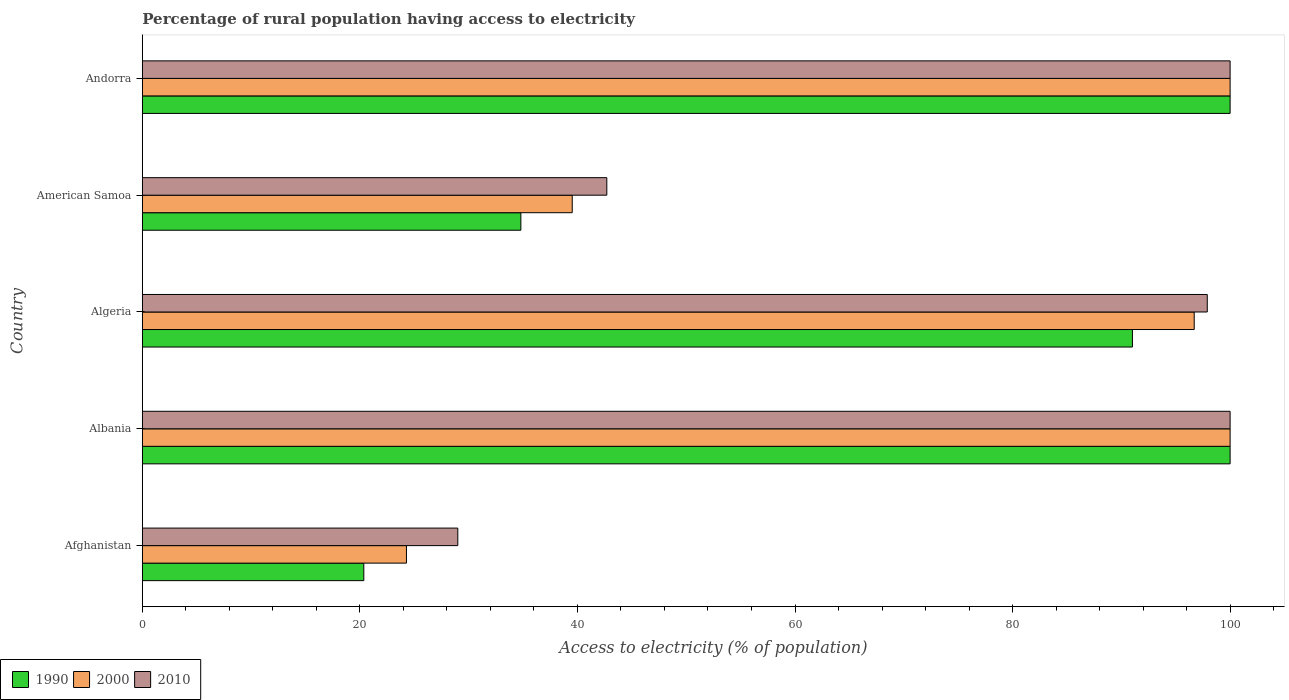Are the number of bars per tick equal to the number of legend labels?
Make the answer very short. Yes. Are the number of bars on each tick of the Y-axis equal?
Give a very brief answer. Yes. How many bars are there on the 4th tick from the bottom?
Ensure brevity in your answer.  3. What is the label of the 5th group of bars from the top?
Ensure brevity in your answer.  Afghanistan. What is the percentage of rural population having access to electricity in 2000 in American Samoa?
Your response must be concise. 39.52. In which country was the percentage of rural population having access to electricity in 2010 maximum?
Ensure brevity in your answer.  Albania. In which country was the percentage of rural population having access to electricity in 1990 minimum?
Keep it short and to the point. Afghanistan. What is the total percentage of rural population having access to electricity in 2000 in the graph?
Ensure brevity in your answer.  360.5. What is the difference between the percentage of rural population having access to electricity in 2010 in Afghanistan and that in Algeria?
Offer a terse response. -68.9. What is the difference between the percentage of rural population having access to electricity in 2000 in Andorra and the percentage of rural population having access to electricity in 1990 in Algeria?
Give a very brief answer. 8.98. What is the average percentage of rural population having access to electricity in 2010 per country?
Provide a succinct answer. 73.92. What is the difference between the percentage of rural population having access to electricity in 2010 and percentage of rural population having access to electricity in 2000 in Afghanistan?
Offer a terse response. 4.72. What is the ratio of the percentage of rural population having access to electricity in 2000 in Afghanistan to that in American Samoa?
Your response must be concise. 0.61. Is the percentage of rural population having access to electricity in 1990 in Albania less than that in Andorra?
Offer a terse response. No. Is the difference between the percentage of rural population having access to electricity in 2010 in Afghanistan and Albania greater than the difference between the percentage of rural population having access to electricity in 2000 in Afghanistan and Albania?
Ensure brevity in your answer.  Yes. Is the sum of the percentage of rural population having access to electricity in 2010 in Afghanistan and American Samoa greater than the maximum percentage of rural population having access to electricity in 2000 across all countries?
Your answer should be very brief. No. How many bars are there?
Give a very brief answer. 15. How many countries are there in the graph?
Make the answer very short. 5. Does the graph contain grids?
Your answer should be very brief. No. What is the title of the graph?
Keep it short and to the point. Percentage of rural population having access to electricity. Does "1968" appear as one of the legend labels in the graph?
Offer a very short reply. No. What is the label or title of the X-axis?
Offer a terse response. Access to electricity (% of population). What is the Access to electricity (% of population) in 1990 in Afghanistan?
Provide a short and direct response. 20.36. What is the Access to electricity (% of population) in 2000 in Afghanistan?
Ensure brevity in your answer.  24.28. What is the Access to electricity (% of population) in 2010 in Afghanistan?
Make the answer very short. 29. What is the Access to electricity (% of population) in 2000 in Albania?
Offer a very short reply. 100. What is the Access to electricity (% of population) in 2010 in Albania?
Offer a very short reply. 100. What is the Access to electricity (% of population) in 1990 in Algeria?
Keep it short and to the point. 91.02. What is the Access to electricity (% of population) in 2000 in Algeria?
Your answer should be very brief. 96.7. What is the Access to electricity (% of population) of 2010 in Algeria?
Offer a very short reply. 97.9. What is the Access to electricity (% of population) of 1990 in American Samoa?
Ensure brevity in your answer.  34.8. What is the Access to electricity (% of population) of 2000 in American Samoa?
Offer a terse response. 39.52. What is the Access to electricity (% of population) in 2010 in American Samoa?
Offer a terse response. 42.7. What is the Access to electricity (% of population) in 1990 in Andorra?
Ensure brevity in your answer.  100. What is the Access to electricity (% of population) of 2010 in Andorra?
Give a very brief answer. 100. Across all countries, what is the maximum Access to electricity (% of population) in 1990?
Your response must be concise. 100. Across all countries, what is the minimum Access to electricity (% of population) in 1990?
Provide a succinct answer. 20.36. Across all countries, what is the minimum Access to electricity (% of population) in 2000?
Your response must be concise. 24.28. What is the total Access to electricity (% of population) of 1990 in the graph?
Provide a succinct answer. 346.18. What is the total Access to electricity (% of population) of 2000 in the graph?
Provide a succinct answer. 360.5. What is the total Access to electricity (% of population) in 2010 in the graph?
Your answer should be very brief. 369.6. What is the difference between the Access to electricity (% of population) of 1990 in Afghanistan and that in Albania?
Provide a succinct answer. -79.64. What is the difference between the Access to electricity (% of population) of 2000 in Afghanistan and that in Albania?
Make the answer very short. -75.72. What is the difference between the Access to electricity (% of population) of 2010 in Afghanistan and that in Albania?
Offer a terse response. -71. What is the difference between the Access to electricity (% of population) in 1990 in Afghanistan and that in Algeria?
Provide a succinct answer. -70.66. What is the difference between the Access to electricity (% of population) in 2000 in Afghanistan and that in Algeria?
Offer a terse response. -72.42. What is the difference between the Access to electricity (% of population) of 2010 in Afghanistan and that in Algeria?
Provide a succinct answer. -68.9. What is the difference between the Access to electricity (% of population) of 1990 in Afghanistan and that in American Samoa?
Offer a very short reply. -14.44. What is the difference between the Access to electricity (% of population) in 2000 in Afghanistan and that in American Samoa?
Your answer should be very brief. -15.24. What is the difference between the Access to electricity (% of population) in 2010 in Afghanistan and that in American Samoa?
Your response must be concise. -13.7. What is the difference between the Access to electricity (% of population) of 1990 in Afghanistan and that in Andorra?
Your response must be concise. -79.64. What is the difference between the Access to electricity (% of population) in 2000 in Afghanistan and that in Andorra?
Your answer should be compact. -75.72. What is the difference between the Access to electricity (% of population) in 2010 in Afghanistan and that in Andorra?
Offer a very short reply. -71. What is the difference between the Access to electricity (% of population) in 1990 in Albania and that in Algeria?
Provide a succinct answer. 8.98. What is the difference between the Access to electricity (% of population) of 2010 in Albania and that in Algeria?
Provide a short and direct response. 2.1. What is the difference between the Access to electricity (% of population) in 1990 in Albania and that in American Samoa?
Provide a short and direct response. 65.2. What is the difference between the Access to electricity (% of population) of 2000 in Albania and that in American Samoa?
Offer a terse response. 60.48. What is the difference between the Access to electricity (% of population) of 2010 in Albania and that in American Samoa?
Make the answer very short. 57.3. What is the difference between the Access to electricity (% of population) in 1990 in Albania and that in Andorra?
Ensure brevity in your answer.  0. What is the difference between the Access to electricity (% of population) of 2000 in Albania and that in Andorra?
Your answer should be compact. 0. What is the difference between the Access to electricity (% of population) of 1990 in Algeria and that in American Samoa?
Make the answer very short. 56.22. What is the difference between the Access to electricity (% of population) of 2000 in Algeria and that in American Samoa?
Give a very brief answer. 57.18. What is the difference between the Access to electricity (% of population) of 2010 in Algeria and that in American Samoa?
Your answer should be compact. 55.2. What is the difference between the Access to electricity (% of population) of 1990 in Algeria and that in Andorra?
Your answer should be compact. -8.98. What is the difference between the Access to electricity (% of population) in 2000 in Algeria and that in Andorra?
Keep it short and to the point. -3.3. What is the difference between the Access to electricity (% of population) of 1990 in American Samoa and that in Andorra?
Your answer should be compact. -65.2. What is the difference between the Access to electricity (% of population) of 2000 in American Samoa and that in Andorra?
Provide a short and direct response. -60.48. What is the difference between the Access to electricity (% of population) in 2010 in American Samoa and that in Andorra?
Provide a short and direct response. -57.3. What is the difference between the Access to electricity (% of population) in 1990 in Afghanistan and the Access to electricity (% of population) in 2000 in Albania?
Provide a succinct answer. -79.64. What is the difference between the Access to electricity (% of population) of 1990 in Afghanistan and the Access to electricity (% of population) of 2010 in Albania?
Your response must be concise. -79.64. What is the difference between the Access to electricity (% of population) of 2000 in Afghanistan and the Access to electricity (% of population) of 2010 in Albania?
Keep it short and to the point. -75.72. What is the difference between the Access to electricity (% of population) in 1990 in Afghanistan and the Access to electricity (% of population) in 2000 in Algeria?
Your answer should be compact. -76.34. What is the difference between the Access to electricity (% of population) of 1990 in Afghanistan and the Access to electricity (% of population) of 2010 in Algeria?
Provide a succinct answer. -77.54. What is the difference between the Access to electricity (% of population) of 2000 in Afghanistan and the Access to electricity (% of population) of 2010 in Algeria?
Keep it short and to the point. -73.62. What is the difference between the Access to electricity (% of population) in 1990 in Afghanistan and the Access to electricity (% of population) in 2000 in American Samoa?
Your answer should be very brief. -19.16. What is the difference between the Access to electricity (% of population) of 1990 in Afghanistan and the Access to electricity (% of population) of 2010 in American Samoa?
Give a very brief answer. -22.34. What is the difference between the Access to electricity (% of population) of 2000 in Afghanistan and the Access to electricity (% of population) of 2010 in American Samoa?
Provide a succinct answer. -18.42. What is the difference between the Access to electricity (% of population) of 1990 in Afghanistan and the Access to electricity (% of population) of 2000 in Andorra?
Offer a very short reply. -79.64. What is the difference between the Access to electricity (% of population) in 1990 in Afghanistan and the Access to electricity (% of population) in 2010 in Andorra?
Your answer should be very brief. -79.64. What is the difference between the Access to electricity (% of population) of 2000 in Afghanistan and the Access to electricity (% of population) of 2010 in Andorra?
Keep it short and to the point. -75.72. What is the difference between the Access to electricity (% of population) in 1990 in Albania and the Access to electricity (% of population) in 2000 in American Samoa?
Make the answer very short. 60.48. What is the difference between the Access to electricity (% of population) of 1990 in Albania and the Access to electricity (% of population) of 2010 in American Samoa?
Provide a short and direct response. 57.3. What is the difference between the Access to electricity (% of population) of 2000 in Albania and the Access to electricity (% of population) of 2010 in American Samoa?
Your response must be concise. 57.3. What is the difference between the Access to electricity (% of population) of 1990 in Albania and the Access to electricity (% of population) of 2010 in Andorra?
Offer a terse response. 0. What is the difference between the Access to electricity (% of population) of 1990 in Algeria and the Access to electricity (% of population) of 2000 in American Samoa?
Keep it short and to the point. 51.5. What is the difference between the Access to electricity (% of population) in 1990 in Algeria and the Access to electricity (% of population) in 2010 in American Samoa?
Ensure brevity in your answer.  48.32. What is the difference between the Access to electricity (% of population) in 1990 in Algeria and the Access to electricity (% of population) in 2000 in Andorra?
Keep it short and to the point. -8.98. What is the difference between the Access to electricity (% of population) in 1990 in Algeria and the Access to electricity (% of population) in 2010 in Andorra?
Provide a short and direct response. -8.98. What is the difference between the Access to electricity (% of population) in 2000 in Algeria and the Access to electricity (% of population) in 2010 in Andorra?
Your answer should be very brief. -3.3. What is the difference between the Access to electricity (% of population) in 1990 in American Samoa and the Access to electricity (% of population) in 2000 in Andorra?
Give a very brief answer. -65.2. What is the difference between the Access to electricity (% of population) in 1990 in American Samoa and the Access to electricity (% of population) in 2010 in Andorra?
Offer a very short reply. -65.2. What is the difference between the Access to electricity (% of population) in 2000 in American Samoa and the Access to electricity (% of population) in 2010 in Andorra?
Offer a very short reply. -60.48. What is the average Access to electricity (% of population) of 1990 per country?
Your answer should be very brief. 69.24. What is the average Access to electricity (% of population) of 2000 per country?
Your answer should be very brief. 72.1. What is the average Access to electricity (% of population) of 2010 per country?
Provide a succinct answer. 73.92. What is the difference between the Access to electricity (% of population) in 1990 and Access to electricity (% of population) in 2000 in Afghanistan?
Your answer should be very brief. -3.92. What is the difference between the Access to electricity (% of population) of 1990 and Access to electricity (% of population) of 2010 in Afghanistan?
Offer a very short reply. -8.64. What is the difference between the Access to electricity (% of population) of 2000 and Access to electricity (% of population) of 2010 in Afghanistan?
Offer a very short reply. -4.72. What is the difference between the Access to electricity (% of population) in 1990 and Access to electricity (% of population) in 2000 in Albania?
Ensure brevity in your answer.  0. What is the difference between the Access to electricity (% of population) in 1990 and Access to electricity (% of population) in 2010 in Albania?
Offer a terse response. 0. What is the difference between the Access to electricity (% of population) in 2000 and Access to electricity (% of population) in 2010 in Albania?
Give a very brief answer. 0. What is the difference between the Access to electricity (% of population) in 1990 and Access to electricity (% of population) in 2000 in Algeria?
Your answer should be compact. -5.68. What is the difference between the Access to electricity (% of population) in 1990 and Access to electricity (% of population) in 2010 in Algeria?
Offer a terse response. -6.88. What is the difference between the Access to electricity (% of population) of 2000 and Access to electricity (% of population) of 2010 in Algeria?
Your answer should be compact. -1.2. What is the difference between the Access to electricity (% of population) of 1990 and Access to electricity (% of population) of 2000 in American Samoa?
Provide a succinct answer. -4.72. What is the difference between the Access to electricity (% of population) of 1990 and Access to electricity (% of population) of 2010 in American Samoa?
Provide a short and direct response. -7.9. What is the difference between the Access to electricity (% of population) in 2000 and Access to electricity (% of population) in 2010 in American Samoa?
Keep it short and to the point. -3.18. What is the difference between the Access to electricity (% of population) in 1990 and Access to electricity (% of population) in 2000 in Andorra?
Your response must be concise. 0. What is the difference between the Access to electricity (% of population) of 1990 and Access to electricity (% of population) of 2010 in Andorra?
Offer a terse response. 0. What is the ratio of the Access to electricity (% of population) in 1990 in Afghanistan to that in Albania?
Make the answer very short. 0.2. What is the ratio of the Access to electricity (% of population) in 2000 in Afghanistan to that in Albania?
Offer a terse response. 0.24. What is the ratio of the Access to electricity (% of population) of 2010 in Afghanistan to that in Albania?
Your answer should be compact. 0.29. What is the ratio of the Access to electricity (% of population) in 1990 in Afghanistan to that in Algeria?
Give a very brief answer. 0.22. What is the ratio of the Access to electricity (% of population) of 2000 in Afghanistan to that in Algeria?
Offer a very short reply. 0.25. What is the ratio of the Access to electricity (% of population) in 2010 in Afghanistan to that in Algeria?
Provide a short and direct response. 0.3. What is the ratio of the Access to electricity (% of population) of 1990 in Afghanistan to that in American Samoa?
Offer a very short reply. 0.59. What is the ratio of the Access to electricity (% of population) in 2000 in Afghanistan to that in American Samoa?
Make the answer very short. 0.61. What is the ratio of the Access to electricity (% of population) of 2010 in Afghanistan to that in American Samoa?
Provide a succinct answer. 0.68. What is the ratio of the Access to electricity (% of population) of 1990 in Afghanistan to that in Andorra?
Your answer should be compact. 0.2. What is the ratio of the Access to electricity (% of population) in 2000 in Afghanistan to that in Andorra?
Give a very brief answer. 0.24. What is the ratio of the Access to electricity (% of population) of 2010 in Afghanistan to that in Andorra?
Provide a succinct answer. 0.29. What is the ratio of the Access to electricity (% of population) of 1990 in Albania to that in Algeria?
Your response must be concise. 1.1. What is the ratio of the Access to electricity (% of population) of 2000 in Albania to that in Algeria?
Provide a succinct answer. 1.03. What is the ratio of the Access to electricity (% of population) of 2010 in Albania to that in Algeria?
Your answer should be very brief. 1.02. What is the ratio of the Access to electricity (% of population) of 1990 in Albania to that in American Samoa?
Your answer should be compact. 2.87. What is the ratio of the Access to electricity (% of population) of 2000 in Albania to that in American Samoa?
Your answer should be very brief. 2.53. What is the ratio of the Access to electricity (% of population) of 2010 in Albania to that in American Samoa?
Offer a terse response. 2.34. What is the ratio of the Access to electricity (% of population) in 1990 in Albania to that in Andorra?
Provide a succinct answer. 1. What is the ratio of the Access to electricity (% of population) of 2010 in Albania to that in Andorra?
Offer a terse response. 1. What is the ratio of the Access to electricity (% of population) in 1990 in Algeria to that in American Samoa?
Ensure brevity in your answer.  2.62. What is the ratio of the Access to electricity (% of population) in 2000 in Algeria to that in American Samoa?
Provide a short and direct response. 2.45. What is the ratio of the Access to electricity (% of population) of 2010 in Algeria to that in American Samoa?
Your response must be concise. 2.29. What is the ratio of the Access to electricity (% of population) in 1990 in Algeria to that in Andorra?
Your answer should be very brief. 0.91. What is the ratio of the Access to electricity (% of population) of 1990 in American Samoa to that in Andorra?
Keep it short and to the point. 0.35. What is the ratio of the Access to electricity (% of population) of 2000 in American Samoa to that in Andorra?
Ensure brevity in your answer.  0.4. What is the ratio of the Access to electricity (% of population) of 2010 in American Samoa to that in Andorra?
Make the answer very short. 0.43. What is the difference between the highest and the second highest Access to electricity (% of population) of 2000?
Ensure brevity in your answer.  0. What is the difference between the highest and the lowest Access to electricity (% of population) in 1990?
Your answer should be compact. 79.64. What is the difference between the highest and the lowest Access to electricity (% of population) in 2000?
Your answer should be compact. 75.72. What is the difference between the highest and the lowest Access to electricity (% of population) of 2010?
Provide a short and direct response. 71. 